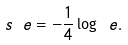Convert formula to latex. <formula><loc_0><loc_0><loc_500><loc_500>s _ { \ } e = - \frac { 1 } { 4 } \log \ e .</formula> 